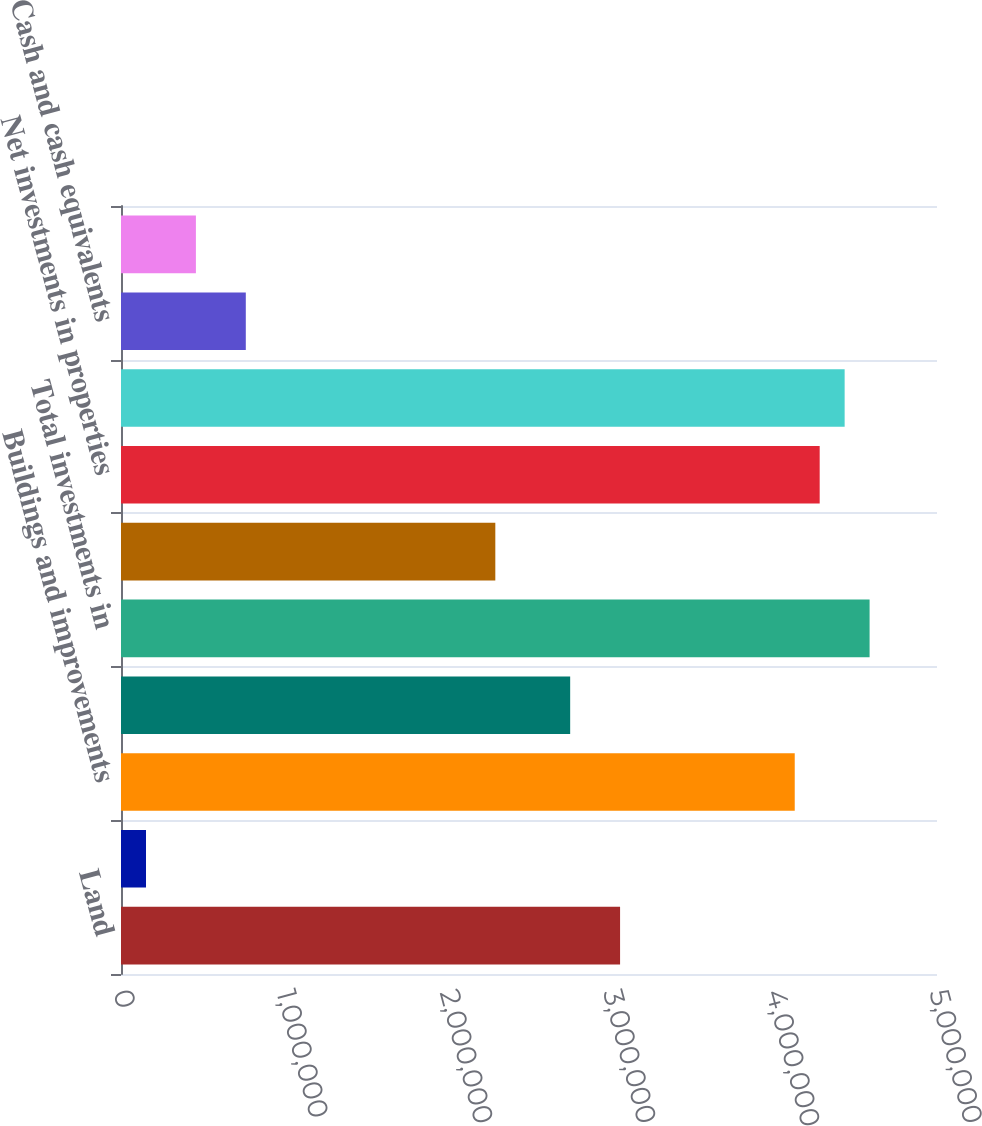Convert chart. <chart><loc_0><loc_0><loc_500><loc_500><bar_chart><fcel>Land<fcel>Acquired ground leases<fcel>Buildings and improvements<fcel>Tenant improvements<fcel>Total investments in<fcel>Accumulated depreciation and<fcel>Net investments in properties<fcel>Net investments in real estate<fcel>Cash and cash equivalents<fcel>Accounts and other receivables<nl><fcel>3.05807e+06<fcel>153164<fcel>4.12829e+06<fcel>2.75229e+06<fcel>4.58696e+06<fcel>2.29362e+06<fcel>4.28118e+06<fcel>4.43407e+06<fcel>764722<fcel>458943<nl></chart> 